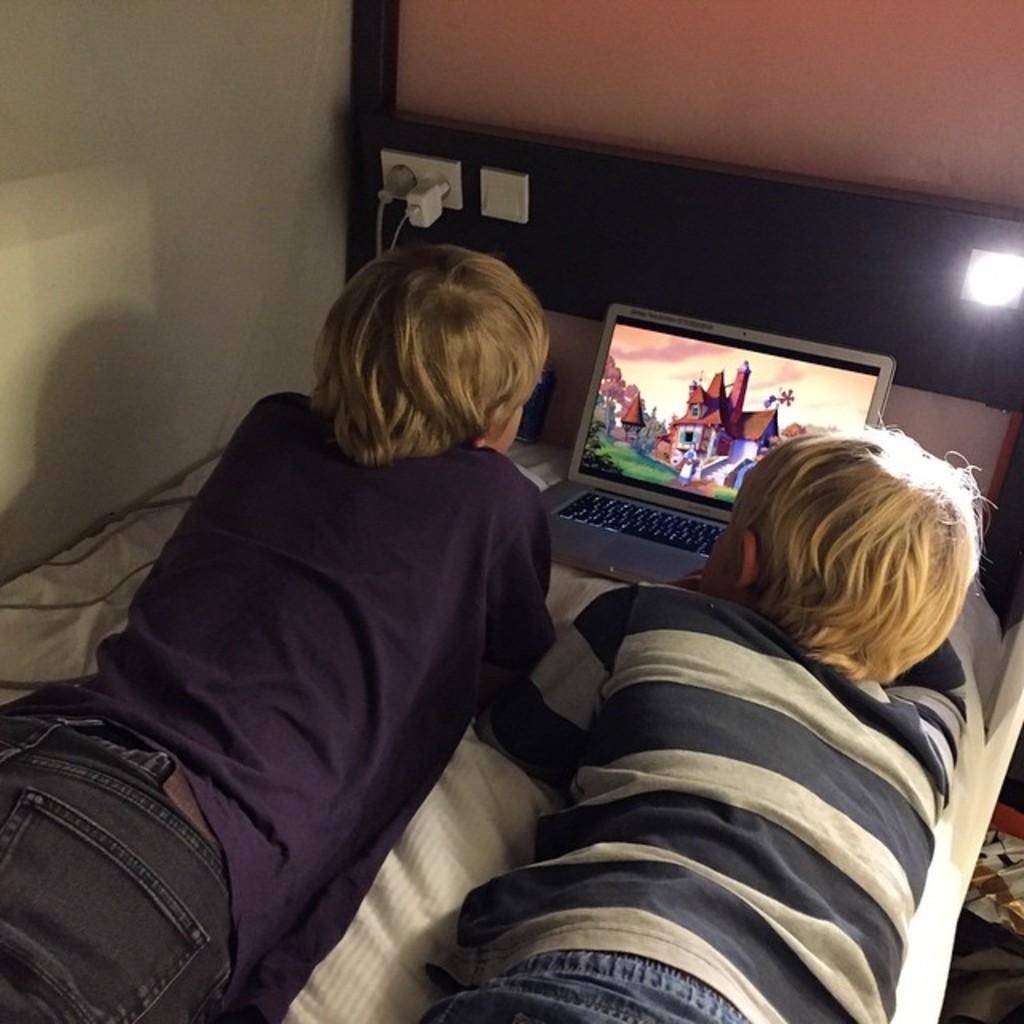Could you give a brief overview of what you see in this image? In this image I can see two people are lying on the bed. In-front of them there is a laptop, light, socket, plugs and wall. 